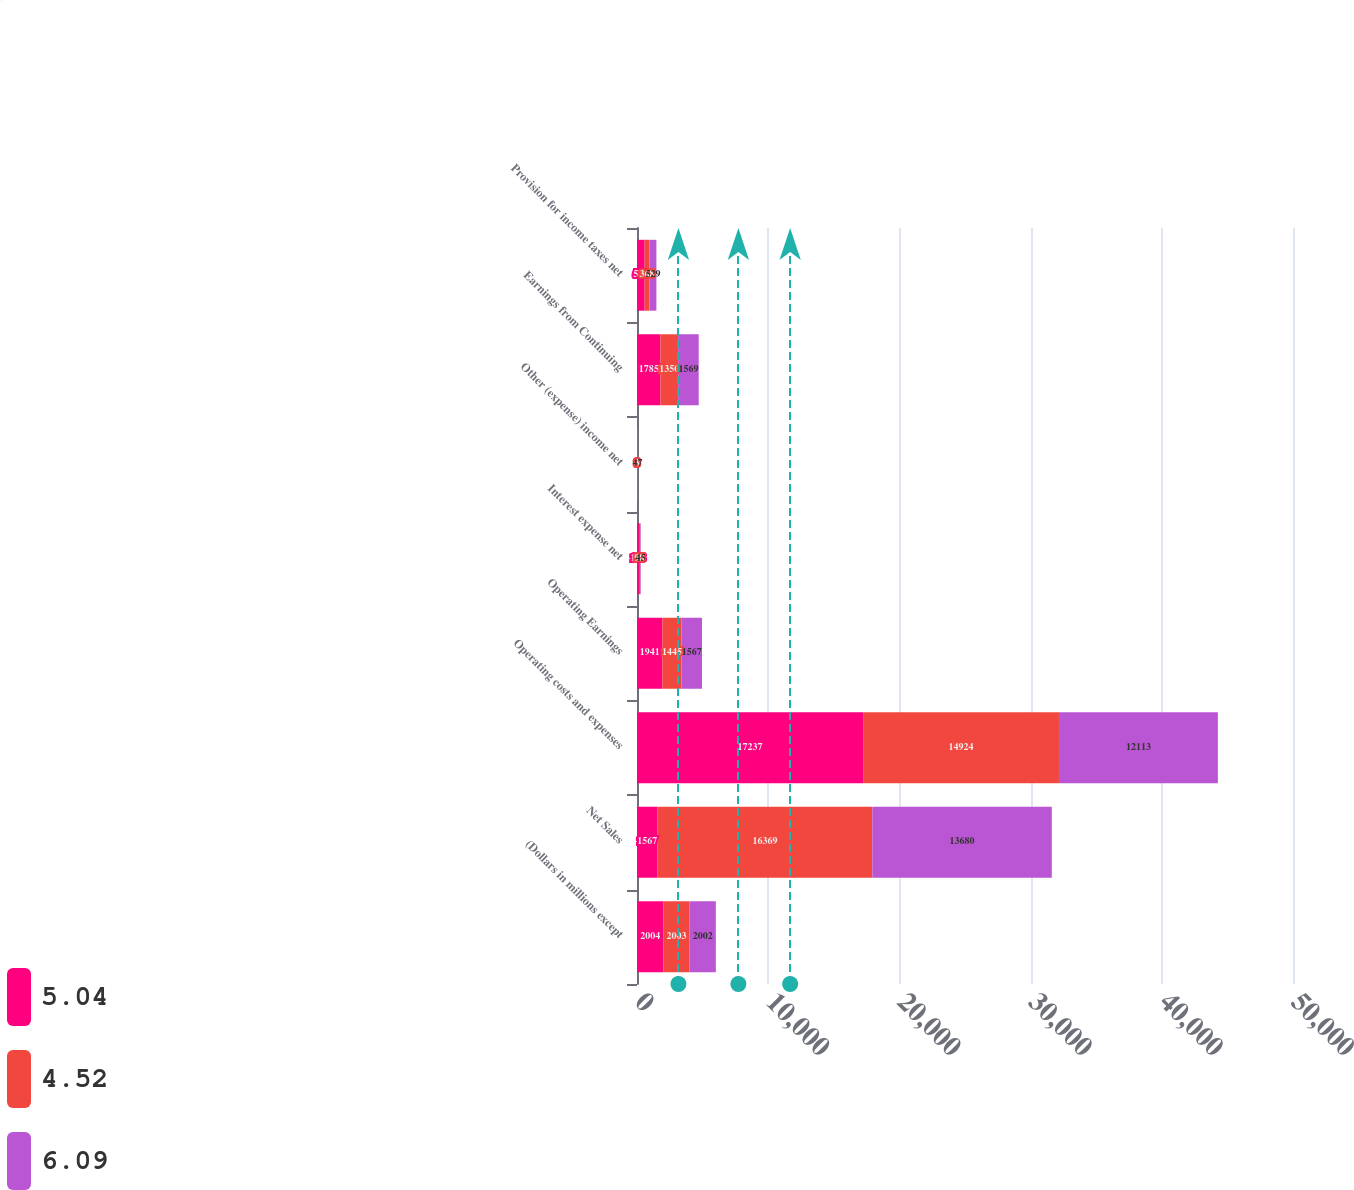Convert chart to OTSL. <chart><loc_0><loc_0><loc_500><loc_500><stacked_bar_chart><ecel><fcel>(Dollars in millions except<fcel>Net Sales<fcel>Operating costs and expenses<fcel>Operating Earnings<fcel>Interest expense net<fcel>Other (expense) income net<fcel>Earnings from Continuing<fcel>Provision for income taxes net<nl><fcel>5.04<fcel>2004<fcel>1567<fcel>17237<fcel>1941<fcel>148<fcel>8<fcel>1785<fcel>582<nl><fcel>4.52<fcel>2003<fcel>16369<fcel>14924<fcel>1445<fcel>98<fcel>3<fcel>1350<fcel>368<nl><fcel>6.09<fcel>2002<fcel>13680<fcel>12113<fcel>1567<fcel>45<fcel>47<fcel>1569<fcel>529<nl></chart> 